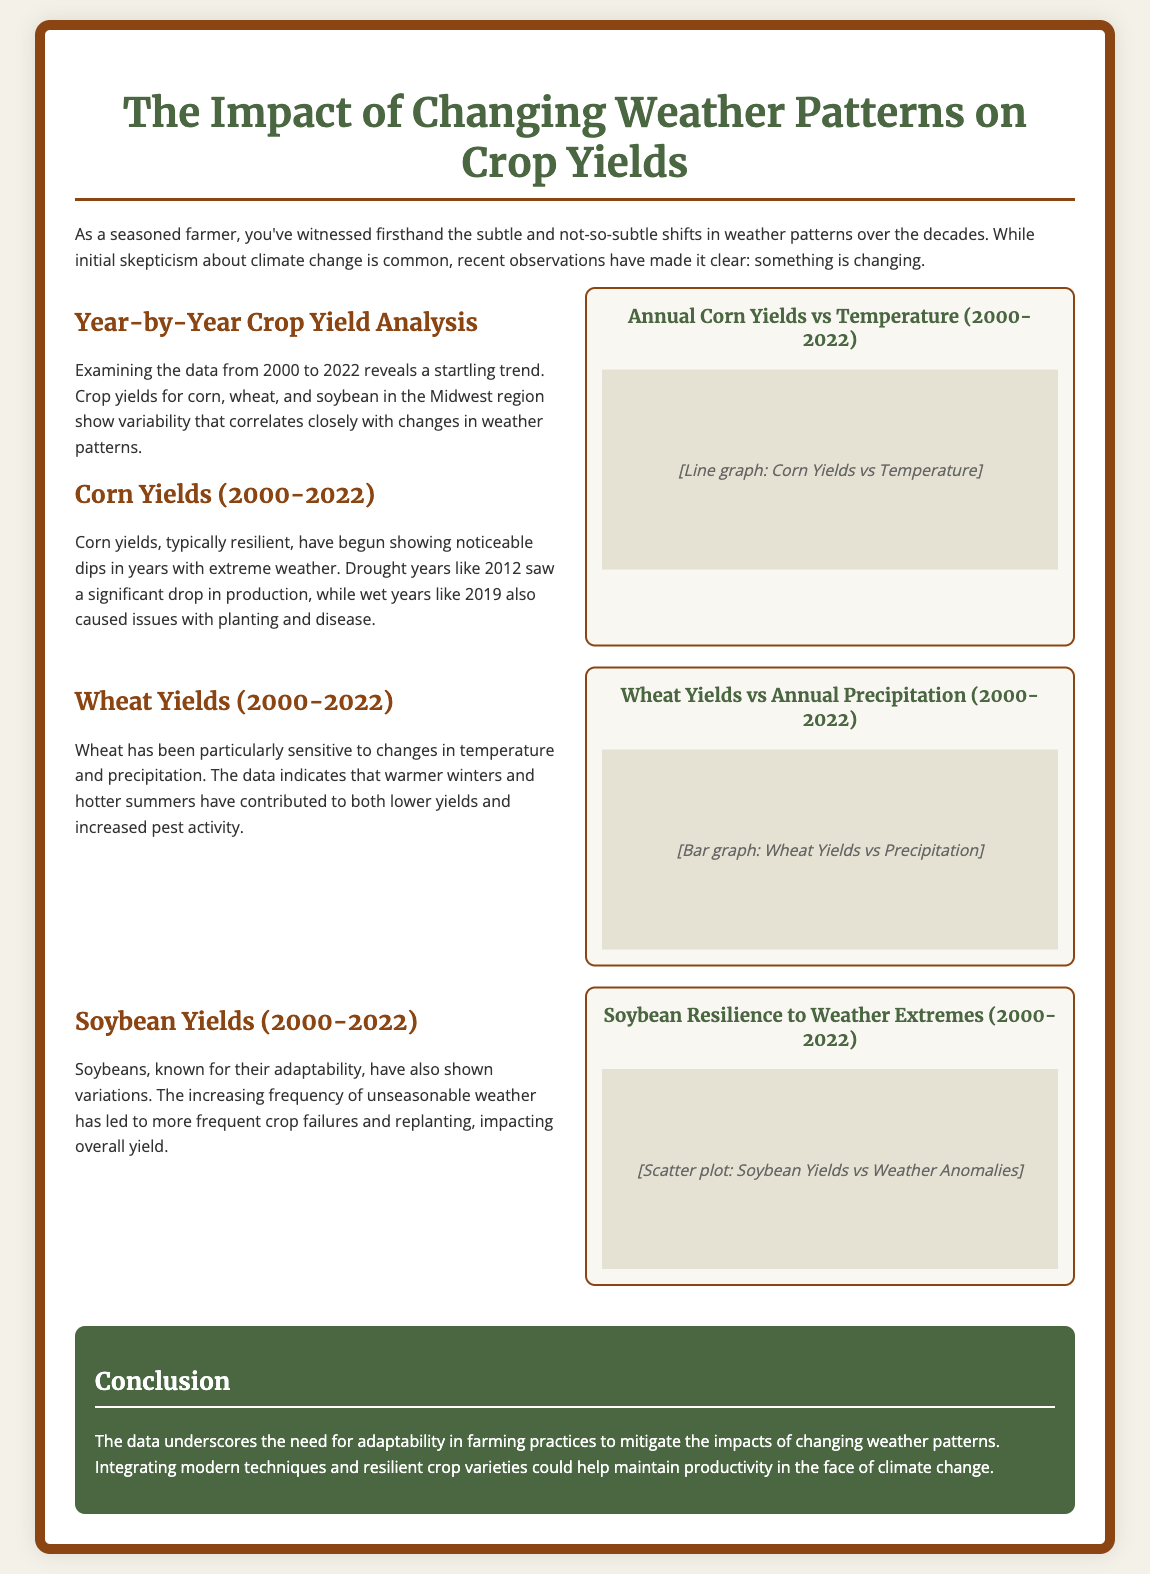What time period does the poster analyze for crop yields? The poster analyzes crop yields from the years 2000 to 2022.
Answer: 2000 to 2022 Which crop showed a significant drop in production during drought years? The poster indicates that corn yields experienced a significant drop during drought years like 2012.
Answer: Corn What does the graph titled "Annual Corn Yields vs Temperature (2000-2022)" illustrate? The graph illustrates the relationship between annual corn yields and temperature over the specified years.
Answer: Corn yields and temperature How have warmer winters affected wheat yields? The poster states that warmer winters have contributed to lower wheat yields and increased pest activity.
Answer: Lower yields What is a significant impact of unseasonable weather on soybean crops? Unseasonable weather has led to more frequent crop failures and replanting, impacting overall yield.
Answer: Crop failures What does the conclusion suggest for farming practices? The conclusion underscores the need for adaptability and integrating modern techniques to mitigate impacts from changing weather patterns.
Answer: Adaptability in farming practices Which crop was noted for their adaptability amidst changing weather patterns? The poster mentions soybeans as being known for their adaptability despite variations in yield.
Answer: Soybeans What year is associated with extreme weather and corn yield decline? The year 2012 is noted in the document for extreme weather impacting corn yields.
Answer: 2012 